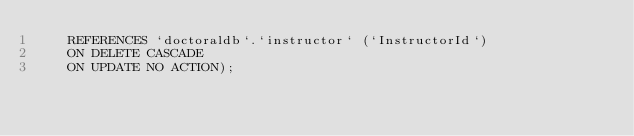<code> <loc_0><loc_0><loc_500><loc_500><_SQL_>    REFERENCES `doctoraldb`.`instructor` (`InstructorId`)
    ON DELETE CASCADE
    ON UPDATE NO ACTION);
    </code> 